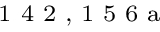Convert formula to latex. <formula><loc_0><loc_0><loc_500><loc_500>^ { 1 } 4 2 , 1 5 6 a</formula> 